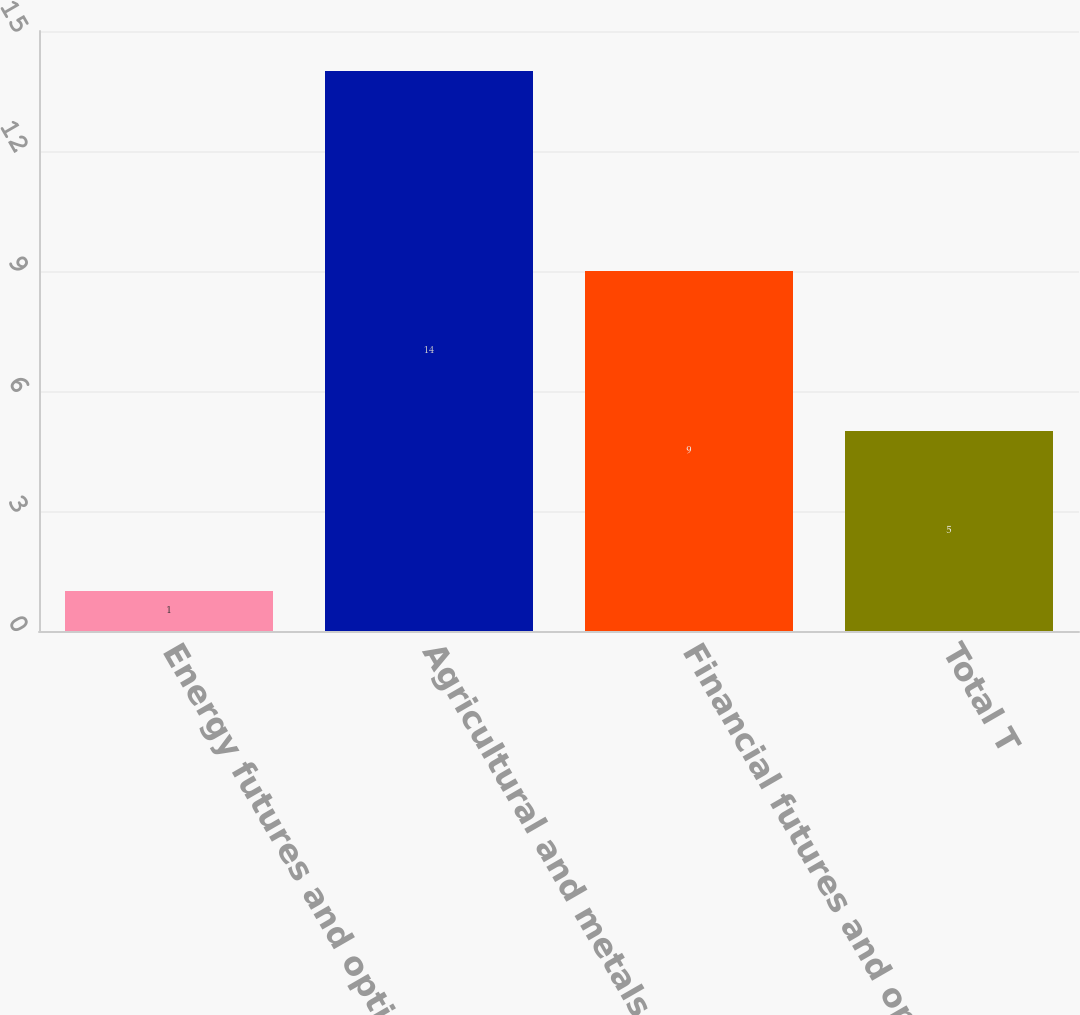Convert chart. <chart><loc_0><loc_0><loc_500><loc_500><bar_chart><fcel>Energy futures and options<fcel>Agricultural and metals<fcel>Financial futures and options<fcel>Total T<nl><fcel>1<fcel>14<fcel>9<fcel>5<nl></chart> 